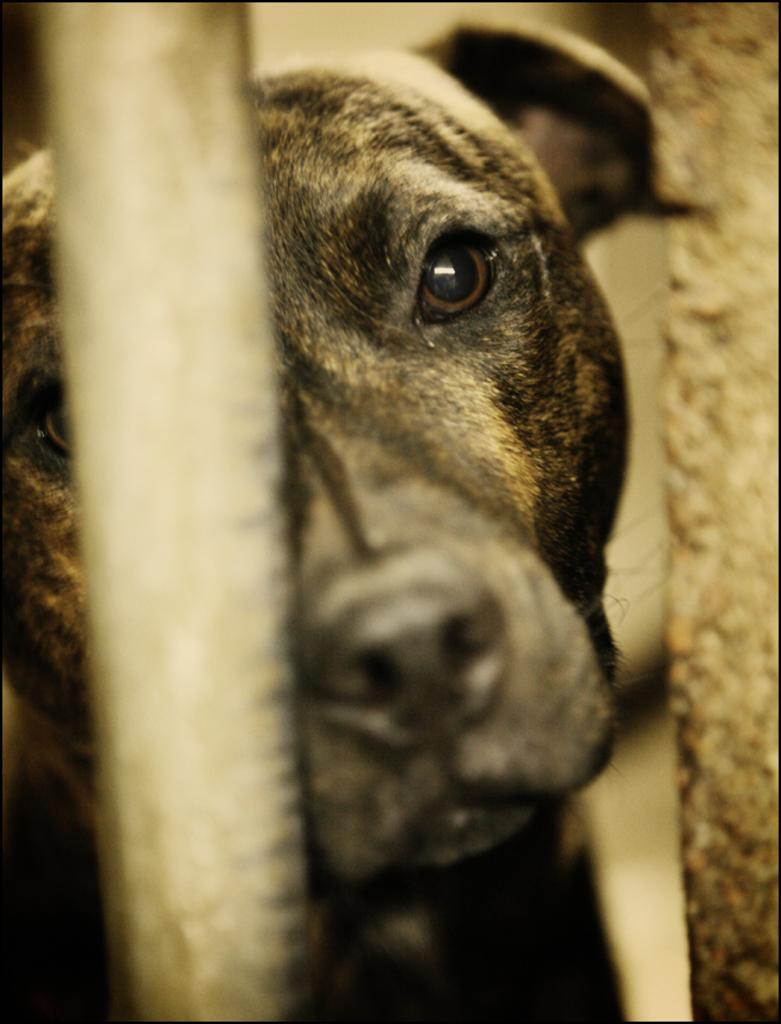What type of animal is in the image? There is a dog in the image. Can you describe the object in front of the dog? Unfortunately, the facts provided do not give any details about the object in front of the dog. How many bikes are visible in the image? There are no bikes present in the image. What type of lace can be seen on the dog's collar in the image? There is no mention of a collar or lace in the image, as it only features a dog and an object in front of it. 